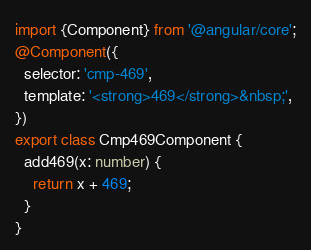<code> <loc_0><loc_0><loc_500><loc_500><_TypeScript_>
import {Component} from '@angular/core';
@Component({
  selector: 'cmp-469',
  template: '<strong>469</strong>&nbsp;',
})
export class Cmp469Component {
  add469(x: number) {
    return x + 469;
  }
}</code> 